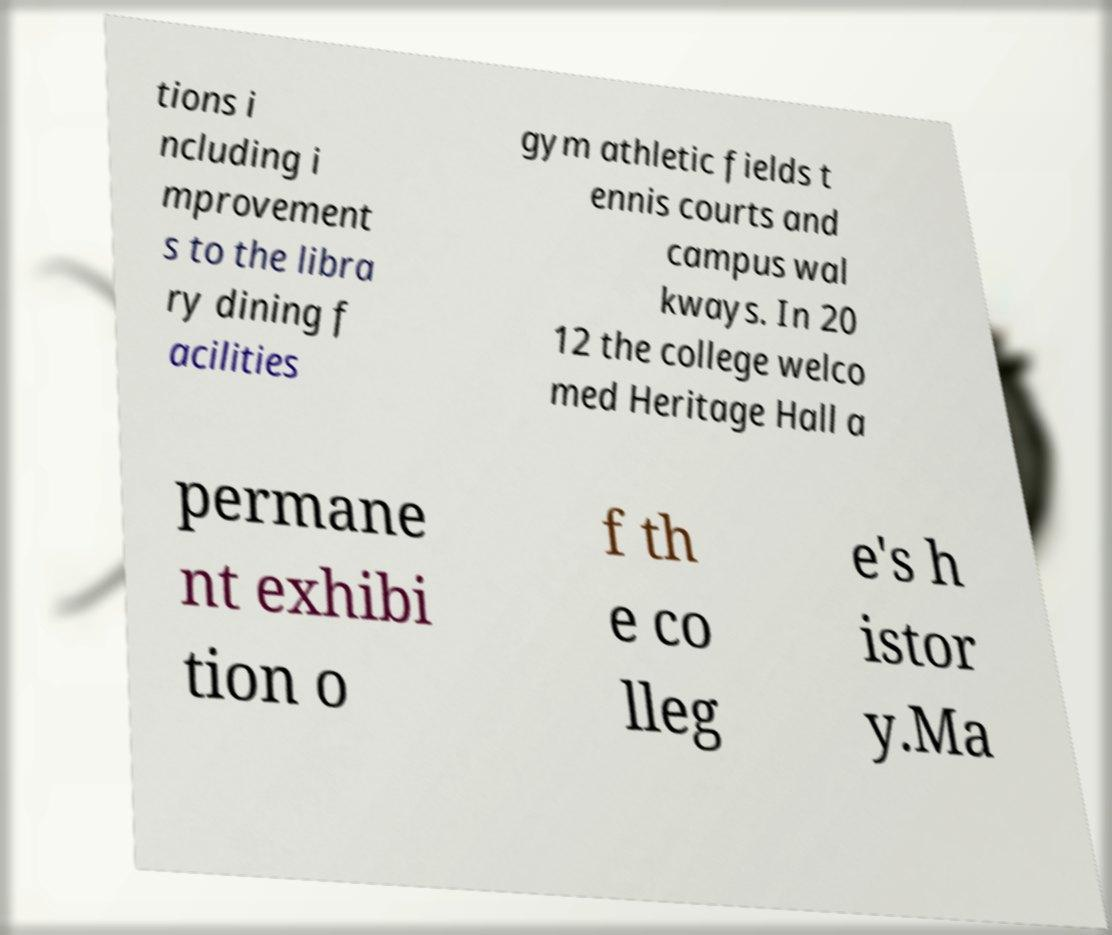Can you read and provide the text displayed in the image?This photo seems to have some interesting text. Can you extract and type it out for me? tions i ncluding i mprovement s to the libra ry dining f acilities gym athletic fields t ennis courts and campus wal kways. In 20 12 the college welco med Heritage Hall a permane nt exhibi tion o f th e co lleg e's h istor y.Ma 